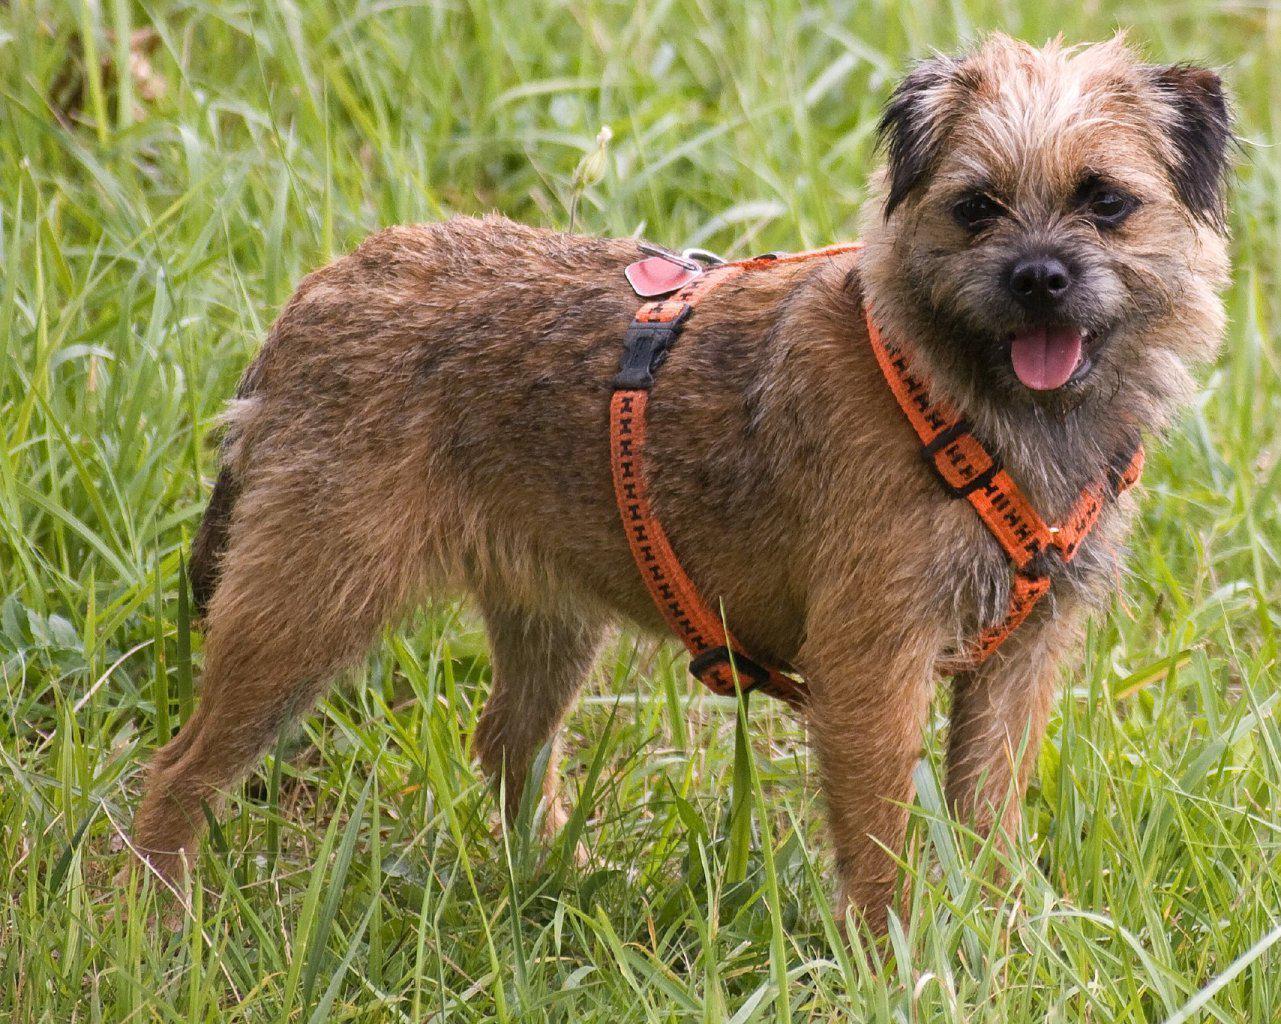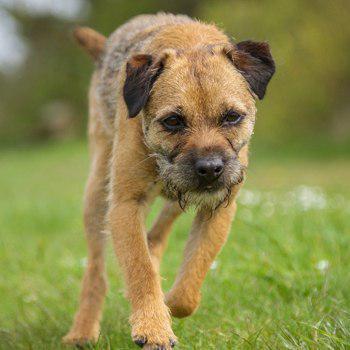The first image is the image on the left, the second image is the image on the right. Considering the images on both sides, is "The right image has exactly one dog who's body is facing towards the left." valid? Answer yes or no. No. 